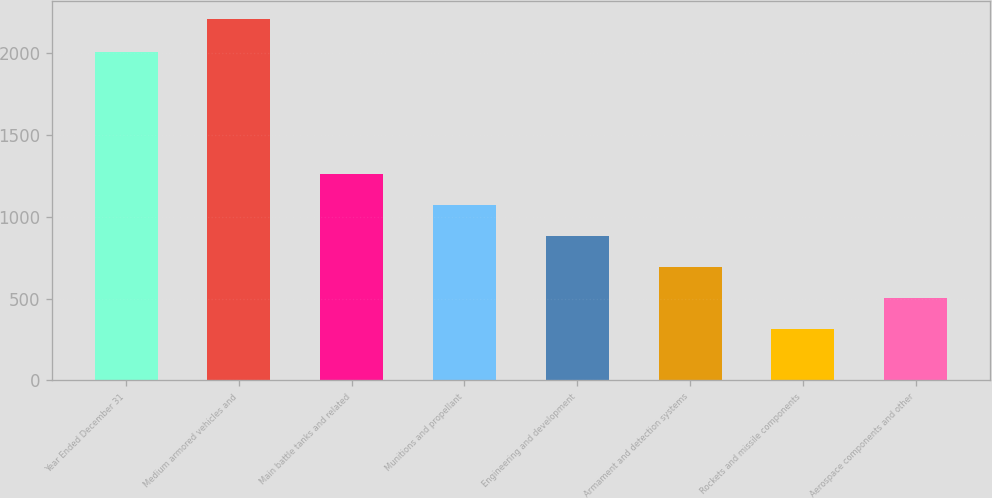<chart> <loc_0><loc_0><loc_500><loc_500><bar_chart><fcel>Year Ended December 31<fcel>Medium armored vehicles and<fcel>Main battle tanks and related<fcel>Munitions and propellant<fcel>Engineering and development<fcel>Armament and detection systems<fcel>Rockets and missile components<fcel>Aerospace components and other<nl><fcel>2006<fcel>2204<fcel>1260.5<fcel>1071.8<fcel>883.1<fcel>694.4<fcel>317<fcel>505.7<nl></chart> 